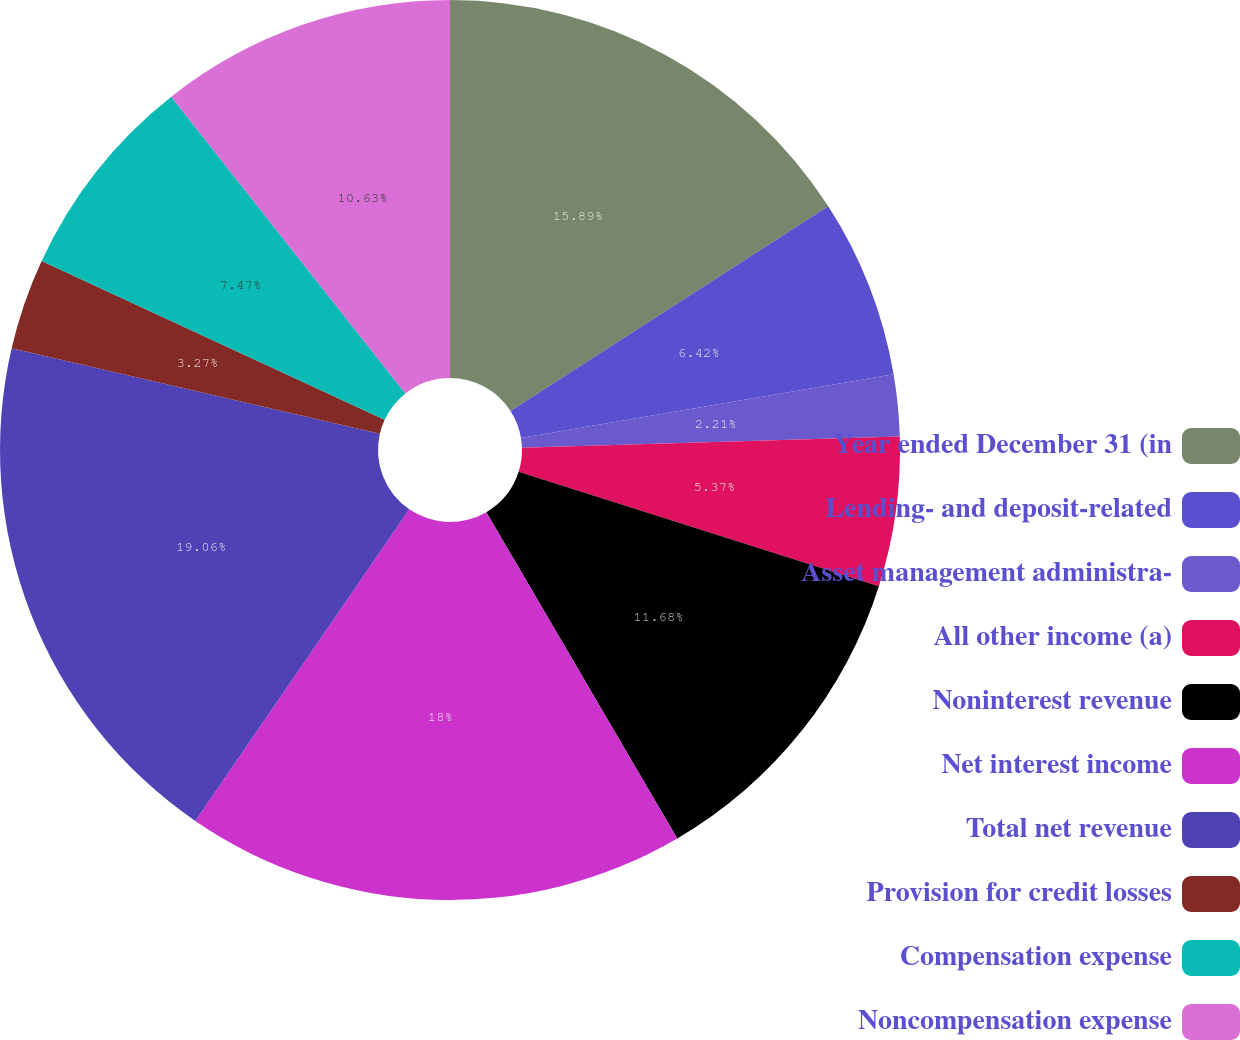Convert chart. <chart><loc_0><loc_0><loc_500><loc_500><pie_chart><fcel>Year ended December 31 (in<fcel>Lending- and deposit-related<fcel>Asset management administra-<fcel>All other income (a)<fcel>Noninterest revenue<fcel>Net interest income<fcel>Total net revenue<fcel>Provision for credit losses<fcel>Compensation expense<fcel>Noncompensation expense<nl><fcel>15.89%<fcel>6.42%<fcel>2.21%<fcel>5.37%<fcel>11.68%<fcel>18.0%<fcel>19.05%<fcel>3.27%<fcel>7.47%<fcel>10.63%<nl></chart> 